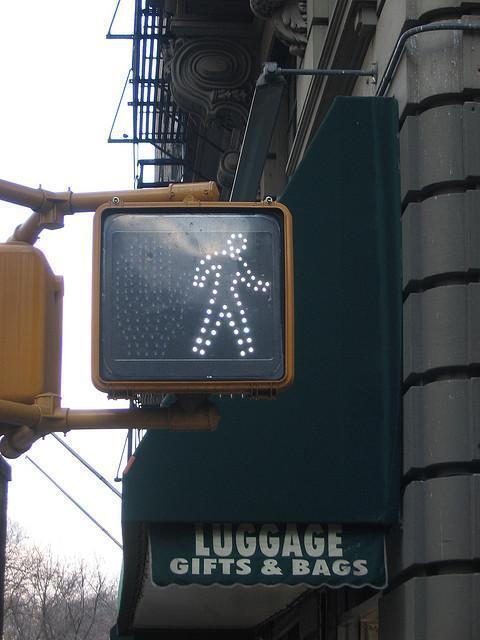How many pizzas can you see?
Give a very brief answer. 0. 